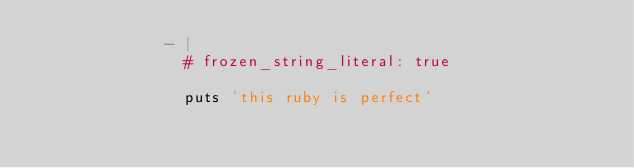<code> <loc_0><loc_0><loc_500><loc_500><_YAML_>              - |
                # frozen_string_literal: true

                puts 'this ruby is perfect'
</code> 